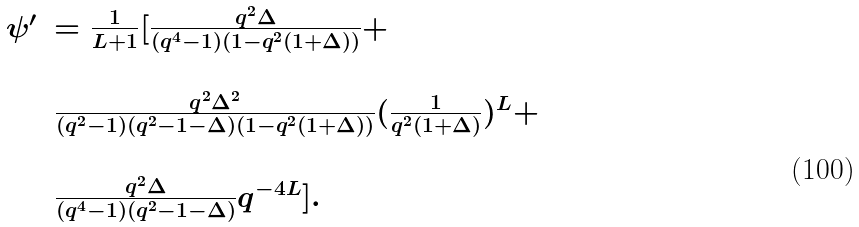<formula> <loc_0><loc_0><loc_500><loc_500>\begin{array} { l l } \psi ^ { \prime } & = \frac { 1 } { L + 1 } [ \frac { q ^ { 2 } \Delta } { ( q ^ { 4 } - 1 ) ( 1 - q ^ { 2 } ( 1 + \Delta ) ) } + \\ \\ & \frac { q ^ { 2 } \Delta ^ { 2 } } { ( q ^ { 2 } - 1 ) ( q ^ { 2 } - 1 - \Delta ) ( 1 - q ^ { 2 } ( 1 + \Delta ) ) } ( \frac { 1 } { q ^ { 2 } ( 1 + \Delta ) } ) ^ { L } + \\ \\ & \frac { q ^ { 2 } \Delta } { ( q ^ { 4 } - 1 ) ( q ^ { 2 } - 1 - \Delta ) } q ^ { - 4 L } ] . \\ \\ \\ \\ \end{array}</formula> 